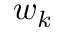Convert formula to latex. <formula><loc_0><loc_0><loc_500><loc_500>w _ { k }</formula> 